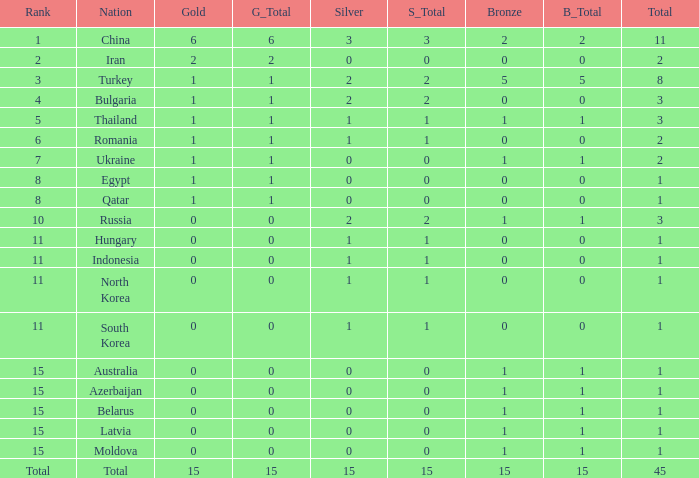What is the highest amount of bronze china, which has more than 1 gold and more than 11 total, has? None. 